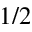<formula> <loc_0><loc_0><loc_500><loc_500>1 / 2</formula> 